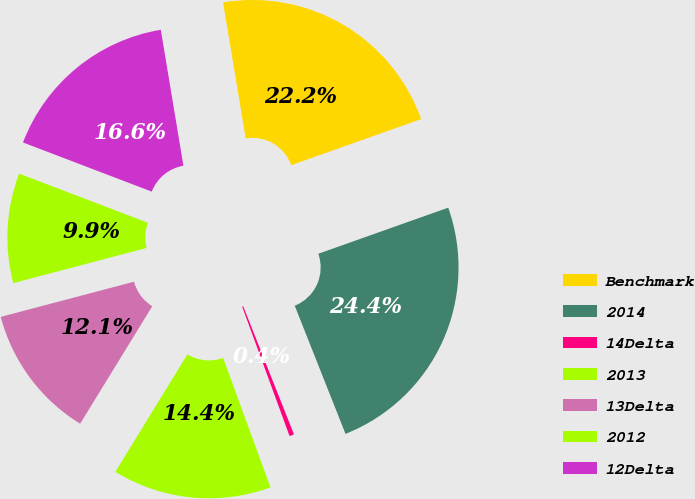<chart> <loc_0><loc_0><loc_500><loc_500><pie_chart><fcel>Benchmark<fcel>2014<fcel>14Delta<fcel>2013<fcel>13Delta<fcel>2012<fcel>12Delta<nl><fcel>22.2%<fcel>24.42%<fcel>0.42%<fcel>14.35%<fcel>12.13%<fcel>9.91%<fcel>16.57%<nl></chart> 